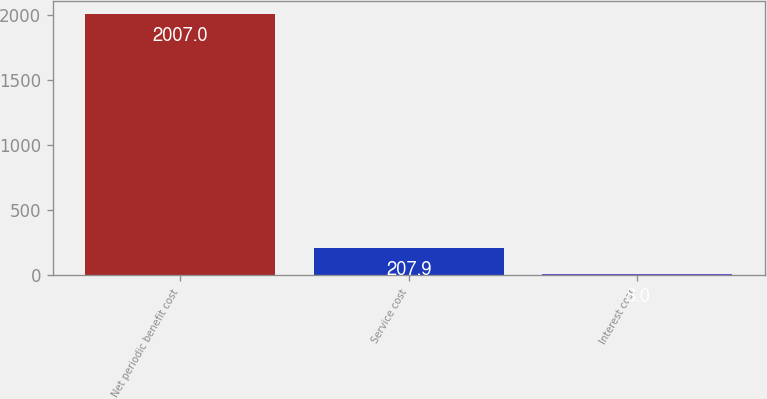Convert chart. <chart><loc_0><loc_0><loc_500><loc_500><bar_chart><fcel>Net periodic benefit cost<fcel>Service cost<fcel>Interest cost<nl><fcel>2007<fcel>207.9<fcel>8<nl></chart> 